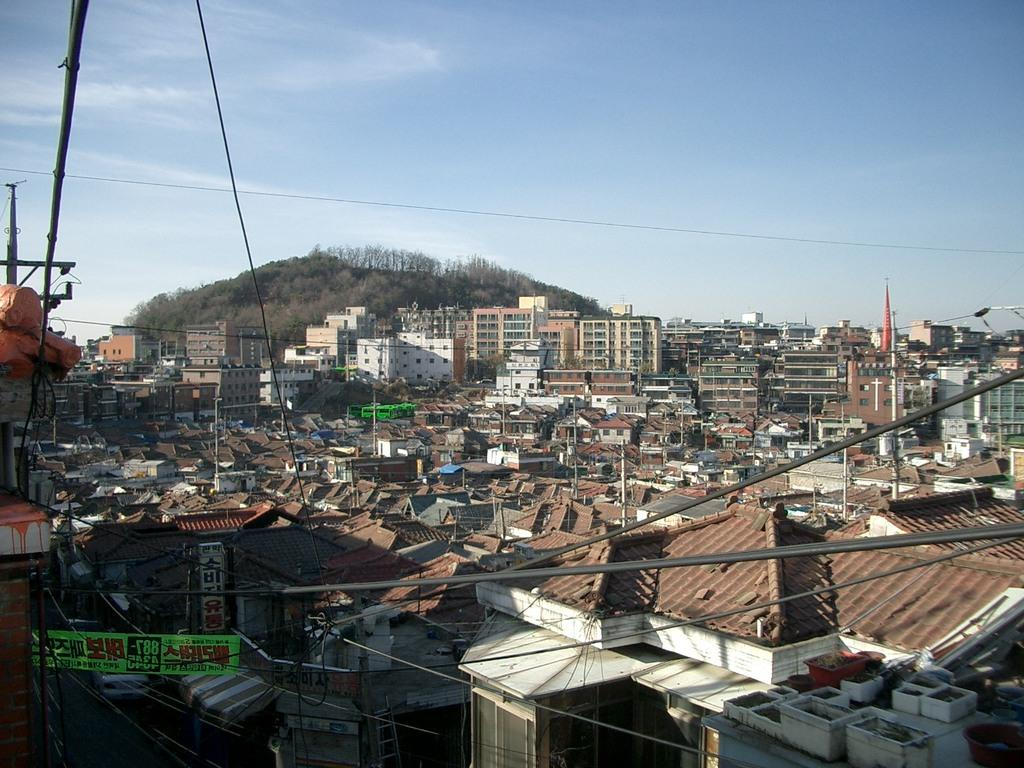What type of objects can be seen in the image that are made of metal? There are metal rods in the image. What other type of objects can be seen in the image? There are wires, houses, buildings, trees, and mountains in the image. What can be seen in the sky in the image? The sky is visible in the image. Can you tell if the image was taken during the day or night? The image was likely taken during the day, as there is no indication of darkness or artificial lighting. Where is the cobweb located in the image? There is no cobweb present in the image. What type of fruit can be seen hanging from the trees in the image? The image does not show any fruit hanging from the trees; it only shows the trees themselves. 